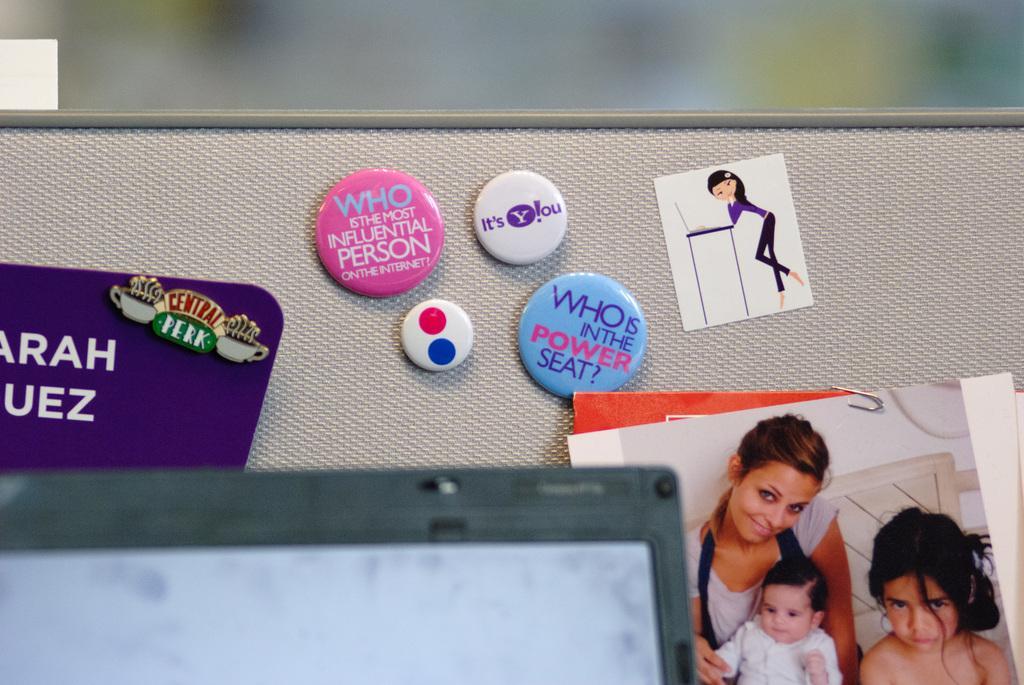Describe this image in one or two sentences. In this image I can see the cream colored surface to which I can see few badges which are pink, white and blue in color are attached and I can see few photographs are also attached to the surface. I can a laptop which is black in color and the blurry background. 